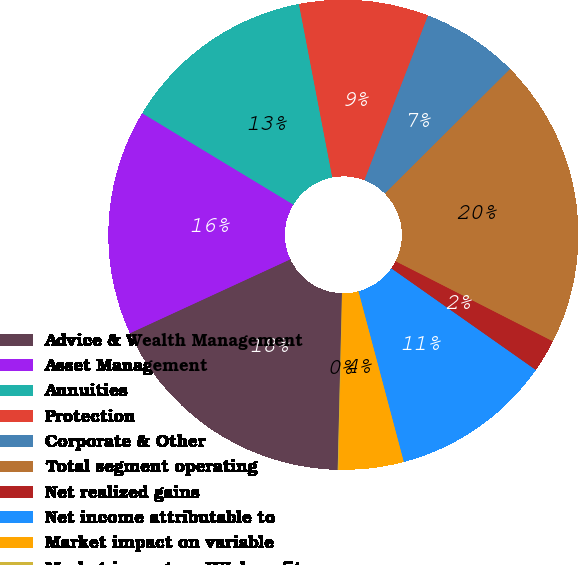Convert chart to OTSL. <chart><loc_0><loc_0><loc_500><loc_500><pie_chart><fcel>Advice & Wealth Management<fcel>Asset Management<fcel>Annuities<fcel>Protection<fcel>Corporate & Other<fcel>Total segment operating<fcel>Net realized gains<fcel>Net income attributable to<fcel>Market impact on variable<fcel>Market impact on IUL benefits<nl><fcel>17.74%<fcel>15.53%<fcel>13.32%<fcel>8.89%<fcel>6.68%<fcel>19.95%<fcel>2.26%<fcel>11.11%<fcel>4.47%<fcel>0.05%<nl></chart> 